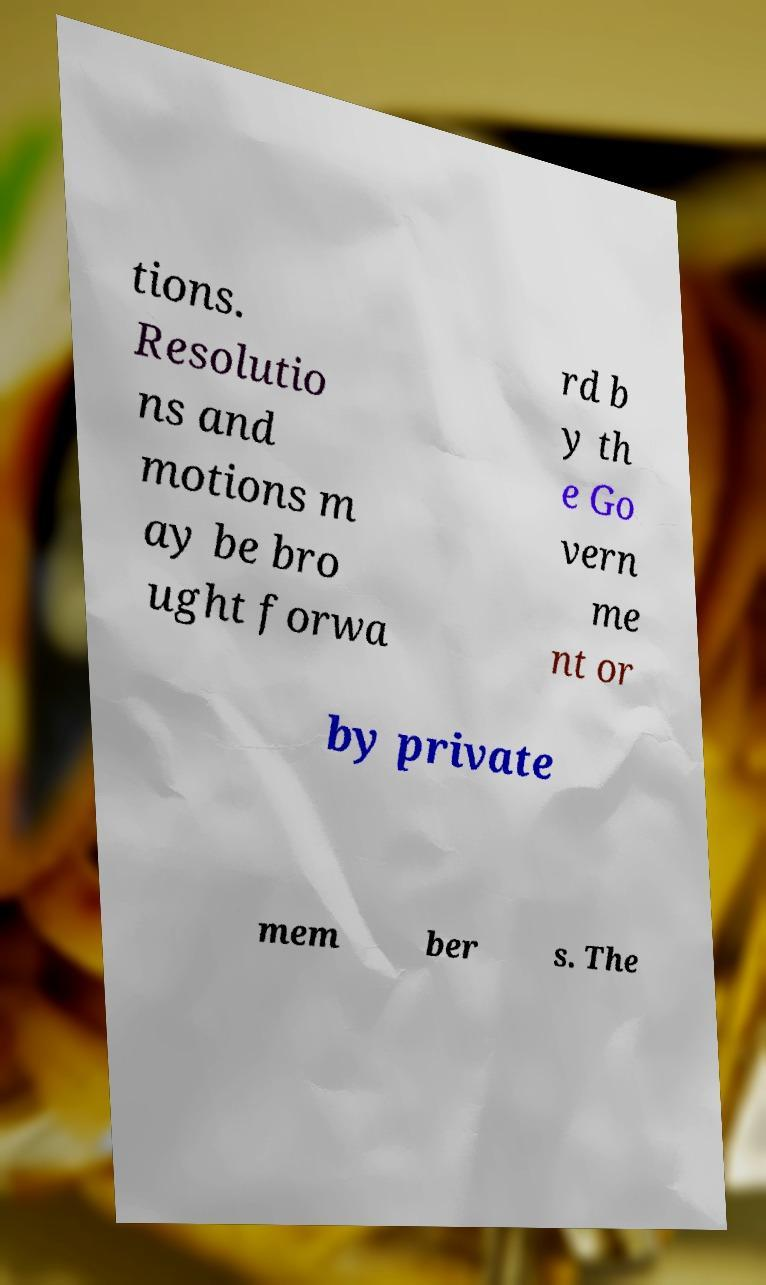Can you accurately transcribe the text from the provided image for me? tions. Resolutio ns and motions m ay be bro ught forwa rd b y th e Go vern me nt or by private mem ber s. The 